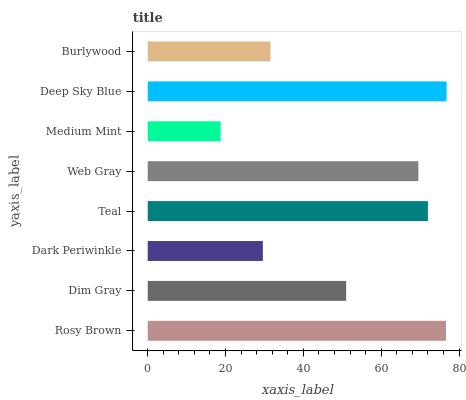Is Medium Mint the minimum?
Answer yes or no. Yes. Is Deep Sky Blue the maximum?
Answer yes or no. Yes. Is Dim Gray the minimum?
Answer yes or no. No. Is Dim Gray the maximum?
Answer yes or no. No. Is Rosy Brown greater than Dim Gray?
Answer yes or no. Yes. Is Dim Gray less than Rosy Brown?
Answer yes or no. Yes. Is Dim Gray greater than Rosy Brown?
Answer yes or no. No. Is Rosy Brown less than Dim Gray?
Answer yes or no. No. Is Web Gray the high median?
Answer yes or no. Yes. Is Dim Gray the low median?
Answer yes or no. Yes. Is Dim Gray the high median?
Answer yes or no. No. Is Rosy Brown the low median?
Answer yes or no. No. 